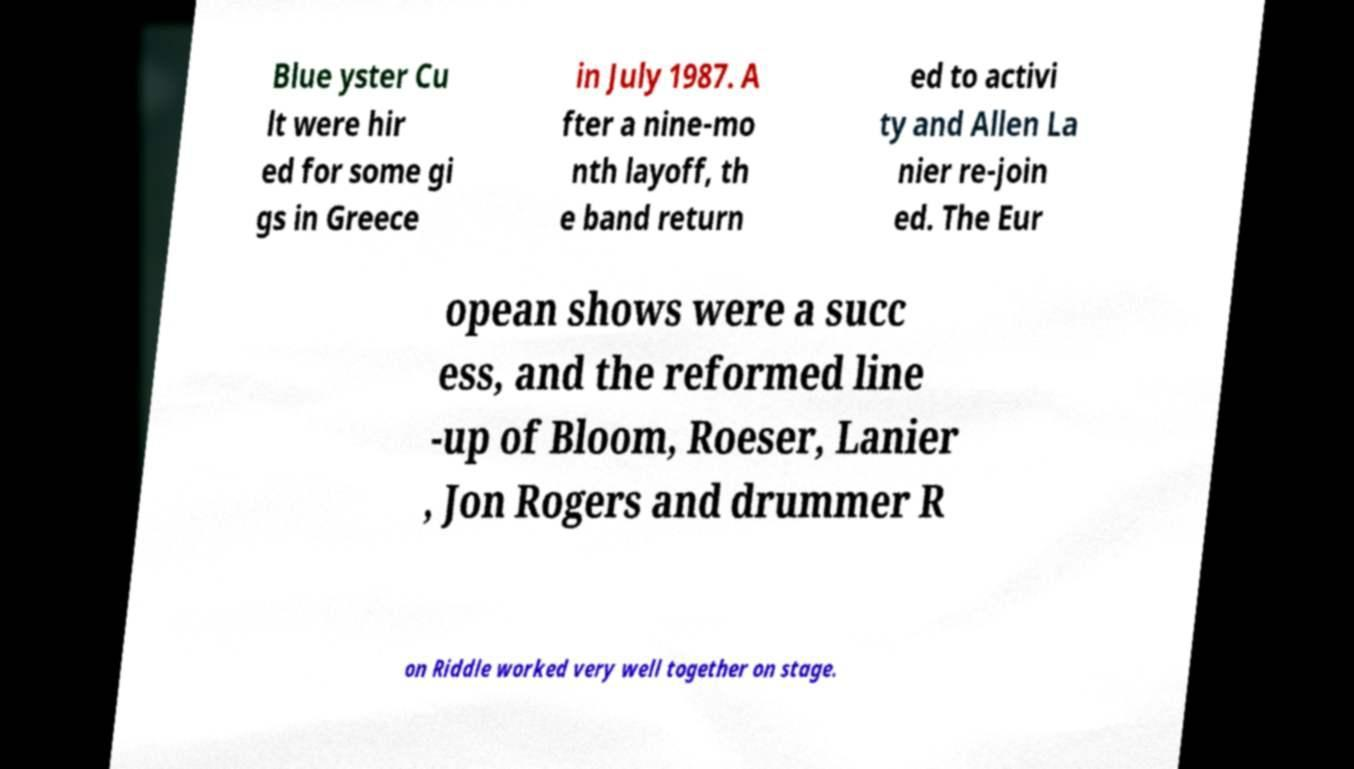There's text embedded in this image that I need extracted. Can you transcribe it verbatim? Blue yster Cu lt were hir ed for some gi gs in Greece in July 1987. A fter a nine-mo nth layoff, th e band return ed to activi ty and Allen La nier re-join ed. The Eur opean shows were a succ ess, and the reformed line -up of Bloom, Roeser, Lanier , Jon Rogers and drummer R on Riddle worked very well together on stage. 